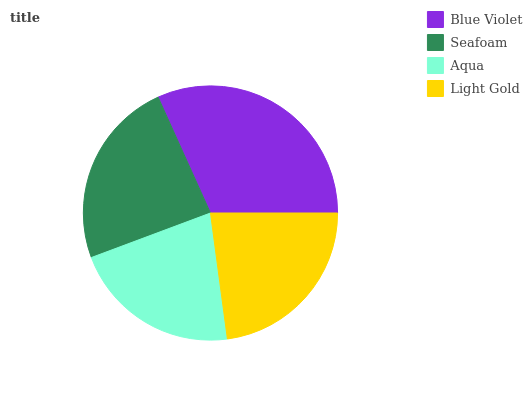Is Aqua the minimum?
Answer yes or no. Yes. Is Blue Violet the maximum?
Answer yes or no. Yes. Is Seafoam the minimum?
Answer yes or no. No. Is Seafoam the maximum?
Answer yes or no. No. Is Blue Violet greater than Seafoam?
Answer yes or no. Yes. Is Seafoam less than Blue Violet?
Answer yes or no. Yes. Is Seafoam greater than Blue Violet?
Answer yes or no. No. Is Blue Violet less than Seafoam?
Answer yes or no. No. Is Seafoam the high median?
Answer yes or no. Yes. Is Light Gold the low median?
Answer yes or no. Yes. Is Aqua the high median?
Answer yes or no. No. Is Aqua the low median?
Answer yes or no. No. 